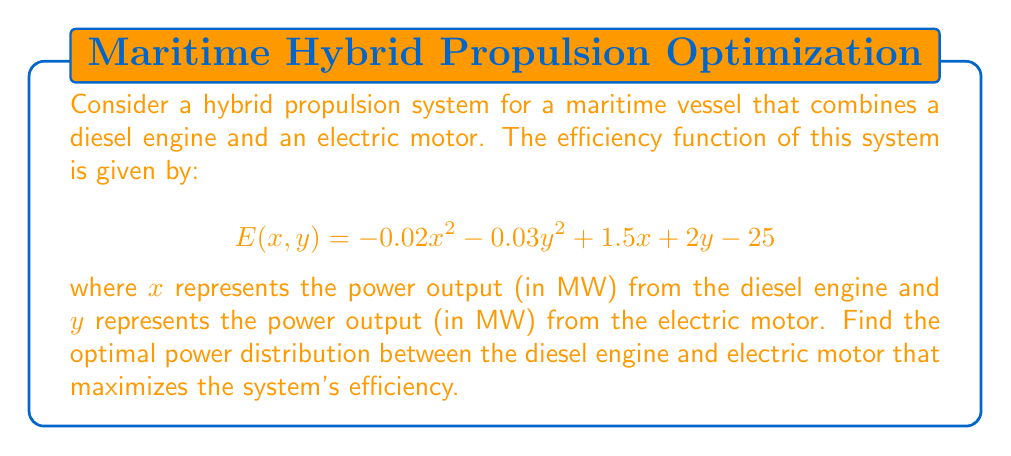Can you solve this math problem? To find the optimal power distribution that maximizes the efficiency, we need to find the maximum of the function $E(x, y)$. This is a nonlinear optimization problem that can be solved using partial derivatives.

Step 1: Calculate the partial derivatives of $E$ with respect to $x$ and $y$.

$$\frac{\partial E}{\partial x} = -0.04x + 1.5$$
$$\frac{\partial E}{\partial y} = -0.06y + 2$$

Step 2: Set both partial derivatives to zero to find the critical points.

$$-0.04x + 1.5 = 0$$
$$-0.06y + 2 = 0$$

Step 3: Solve for $x$ and $y$.

$$x = \frac{1.5}{0.04} = 37.5$$
$$y = \frac{2}{0.06} = 33.33$$

Step 4: Verify that this critical point is a maximum by checking the second partial derivatives.

$$\frac{\partial^2 E}{\partial x^2} = -0.04$$
$$\frac{\partial^2 E}{\partial y^2} = -0.06$$

Since both second partial derivatives are negative, the critical point is a local maximum.

Step 5: Calculate the maximum efficiency.

$$E(37.5, 33.33) = -0.02(37.5)^2 - 0.03(33.33)^2 + 1.5(37.5) + 2(33.33) - 25 \approx 66.67$$
Answer: Optimal power distribution: Diesel engine: 37.5 MW, Electric motor: 33.33 MW. Maximum efficiency: 66.67. 